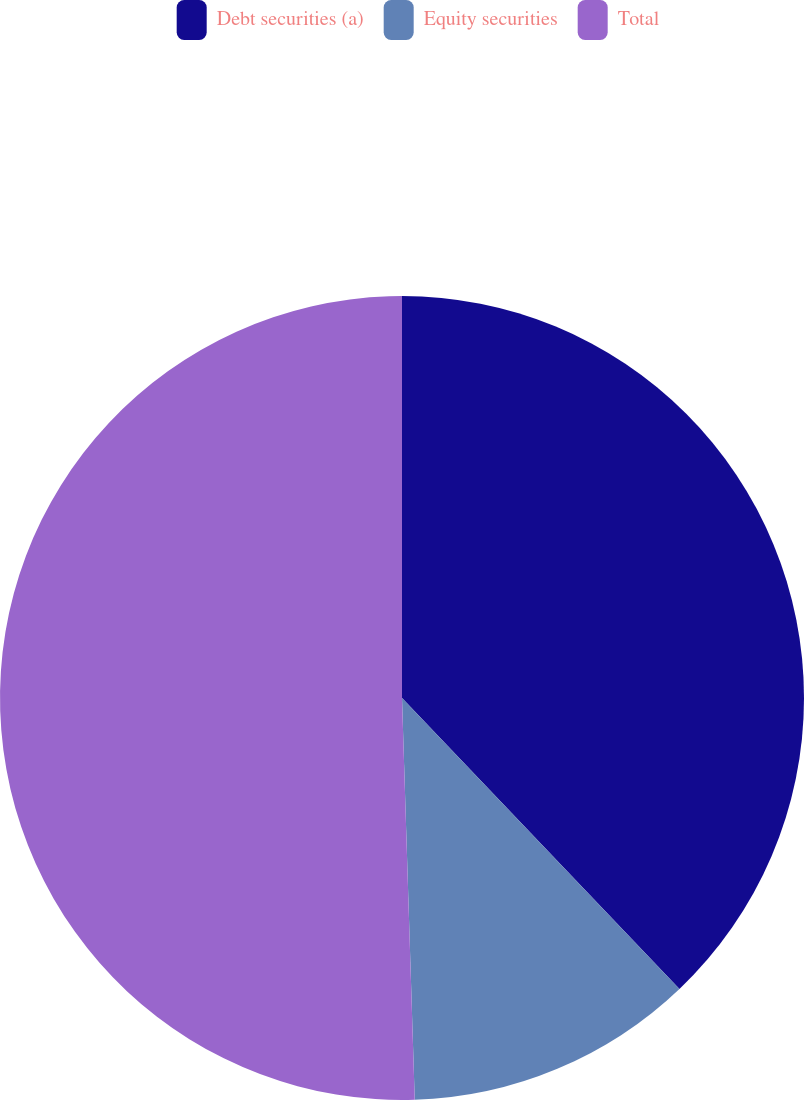<chart> <loc_0><loc_0><loc_500><loc_500><pie_chart><fcel>Debt securities (a)<fcel>Equity securities<fcel>Total<nl><fcel>37.88%<fcel>11.62%<fcel>50.51%<nl></chart> 